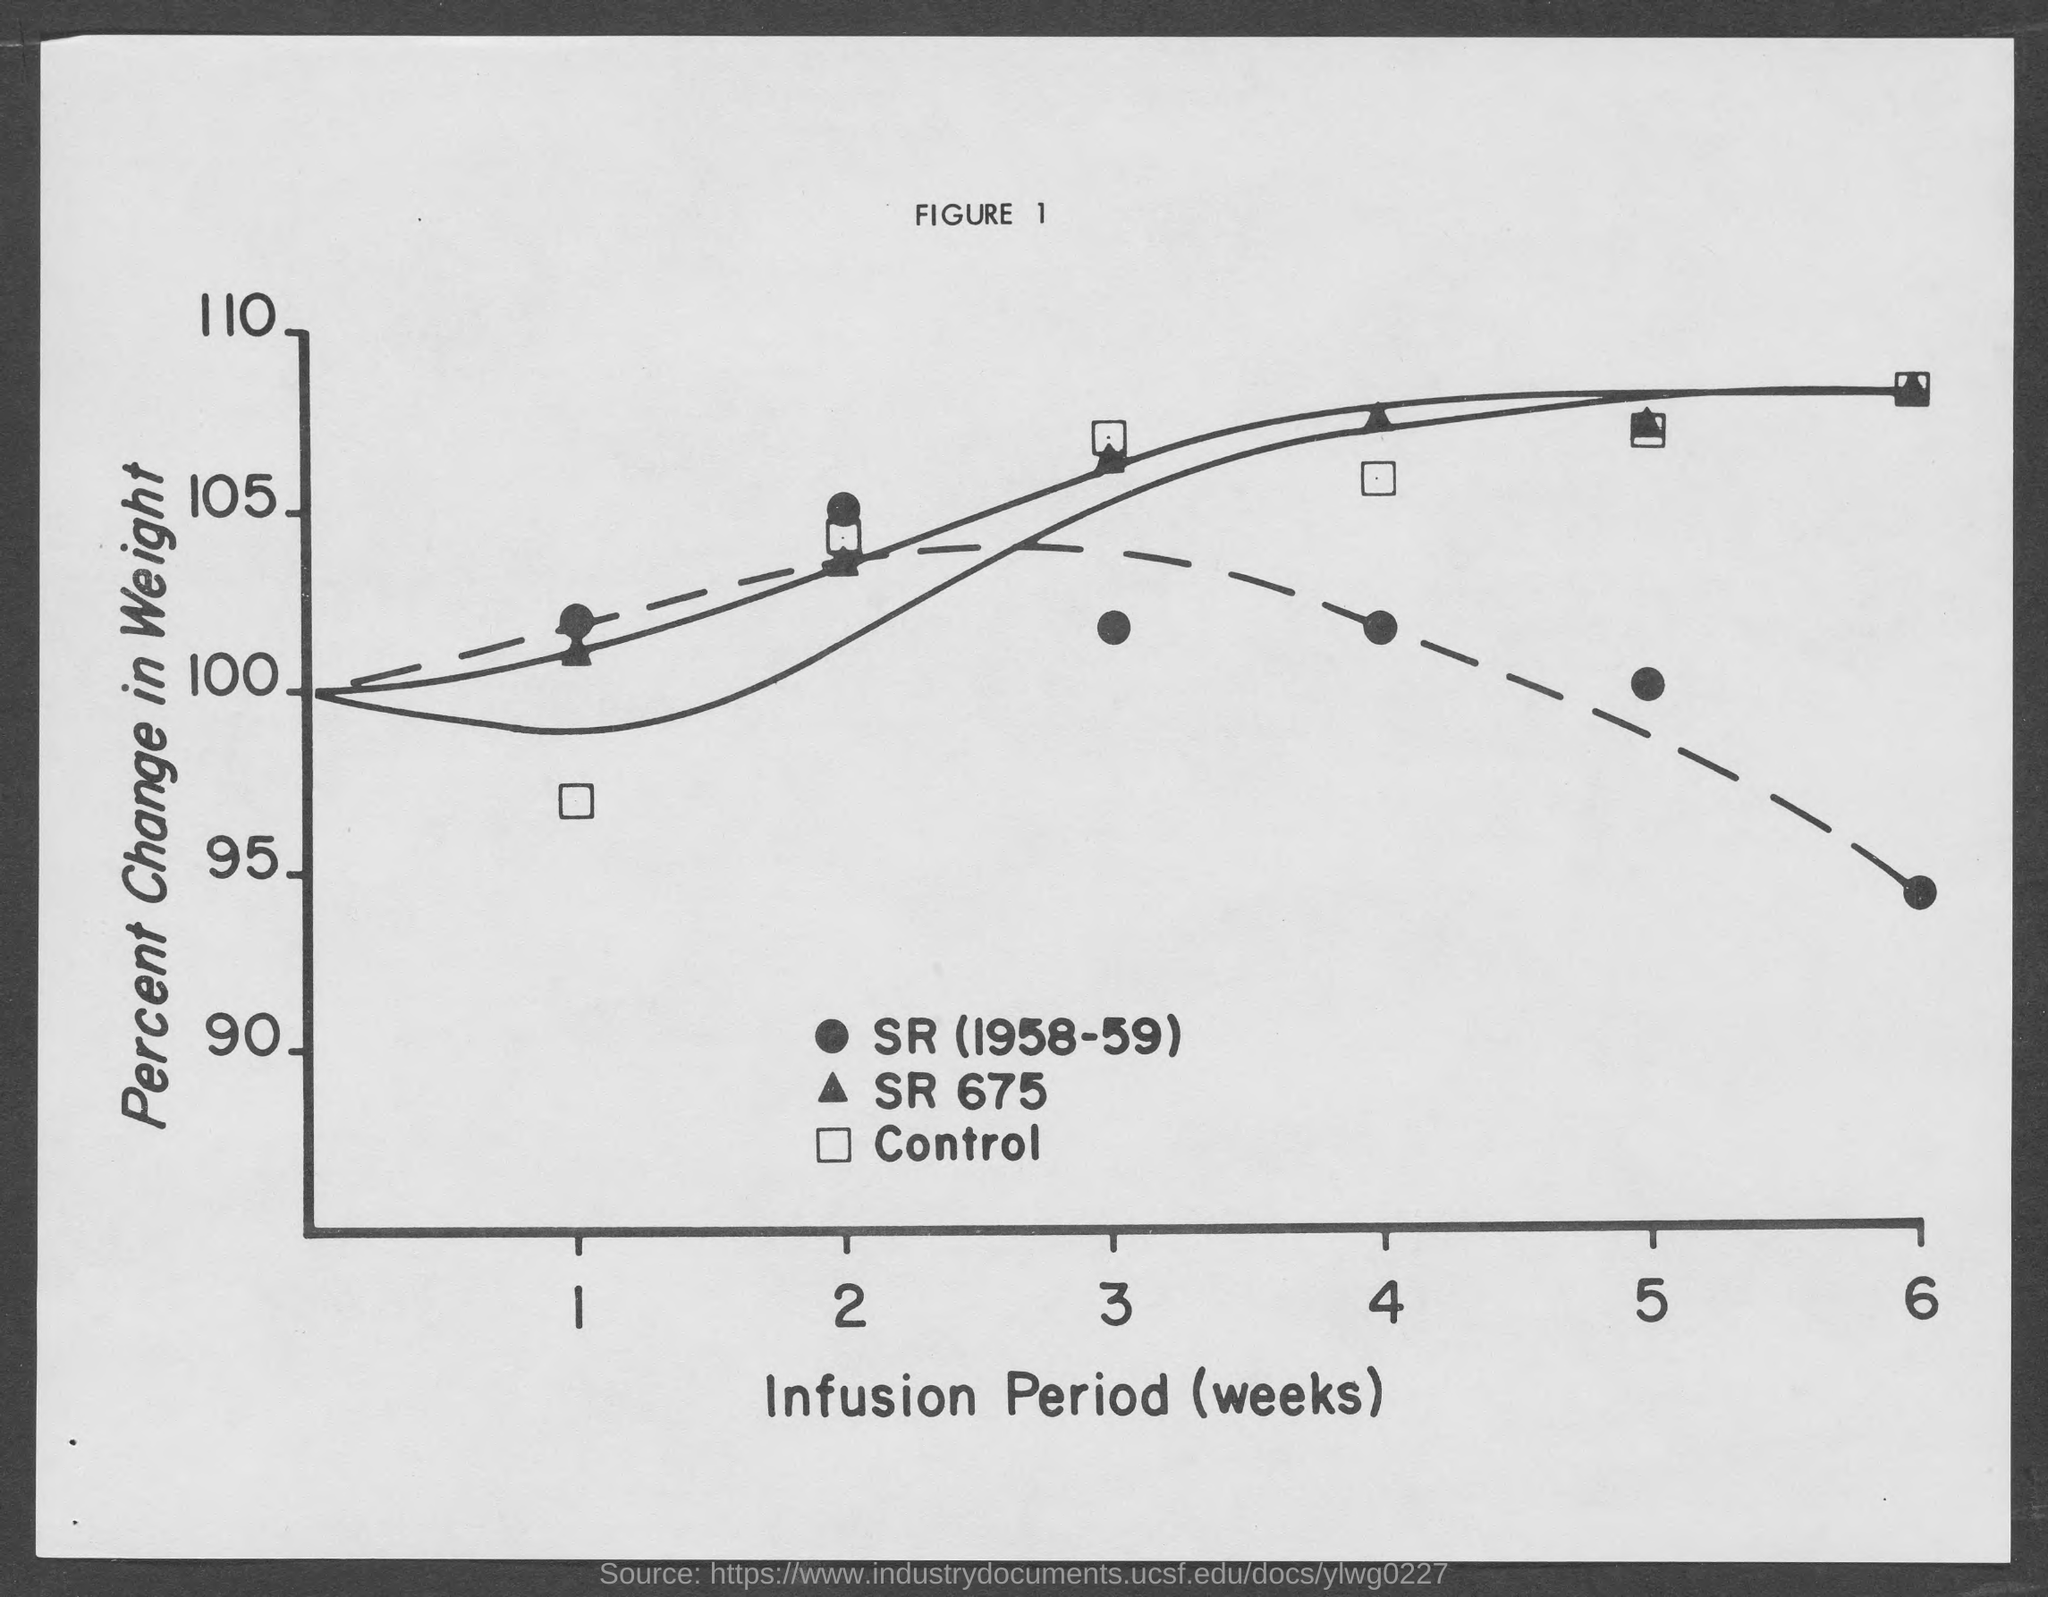What is the figure no.?
Make the answer very short. Figure 1. What is given on y- axis ?
Your response must be concise. Percent change in weight. 